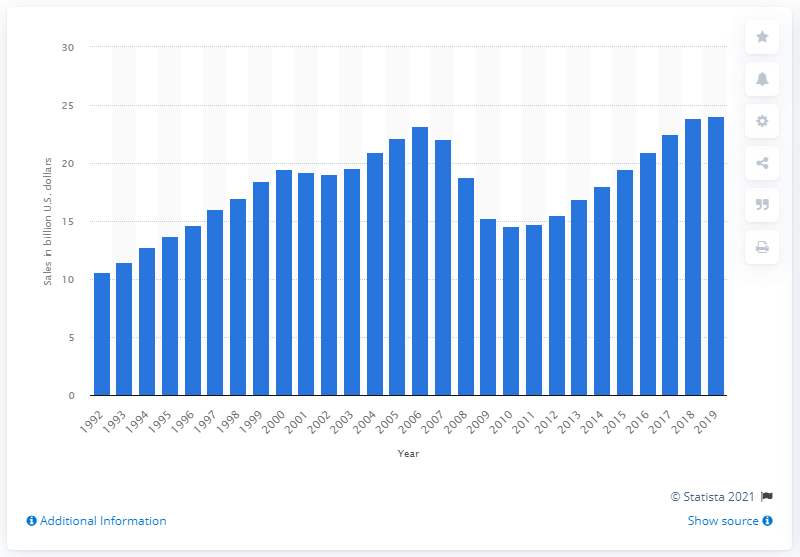Specify some key components in this picture. The sales at the floor covering store one year prior were 24.05.. The sales of floor covering stores in 2019 were $24.05 million. A year earlier, the sales at floor covering stores were approximately $24.05. 